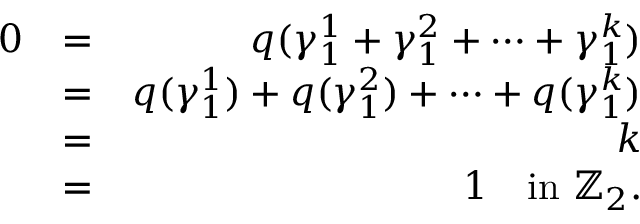Convert formula to latex. <formula><loc_0><loc_0><loc_500><loc_500>\begin{array} { r l r } { 0 } & { = } & { q ( \gamma _ { 1 } ^ { 1 } + \gamma _ { 1 } ^ { 2 } + \cdots + \gamma _ { 1 } ^ { k } ) } \\ & { = } & { q ( \gamma _ { 1 } ^ { 1 } ) + q ( \gamma _ { 1 } ^ { 2 } ) + \cdots + q ( \gamma _ { 1 } ^ { k } ) } \\ & { = } & { k } \\ & { = } & { 1 \quad i n \mathbb { Z } _ { 2 } . } \end{array}</formula> 